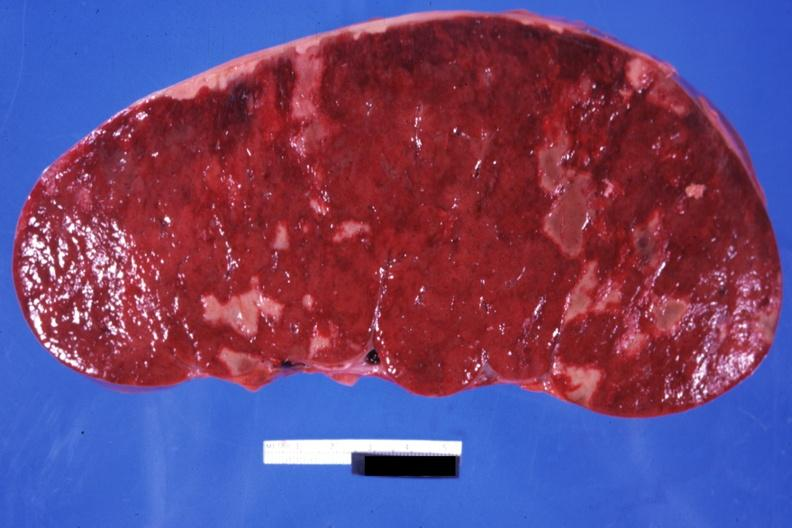where is this part in?
Answer the question using a single word or phrase. Spleen 